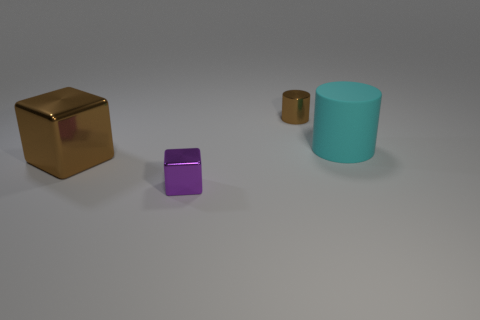Could you describe the lighting in the scene? The lighting in the scene is soft and diffused, coming from above. There are no harsh shadows, indicating a likely indoor setup with ambient lighting, which gives the scene a calm and neutral look. 